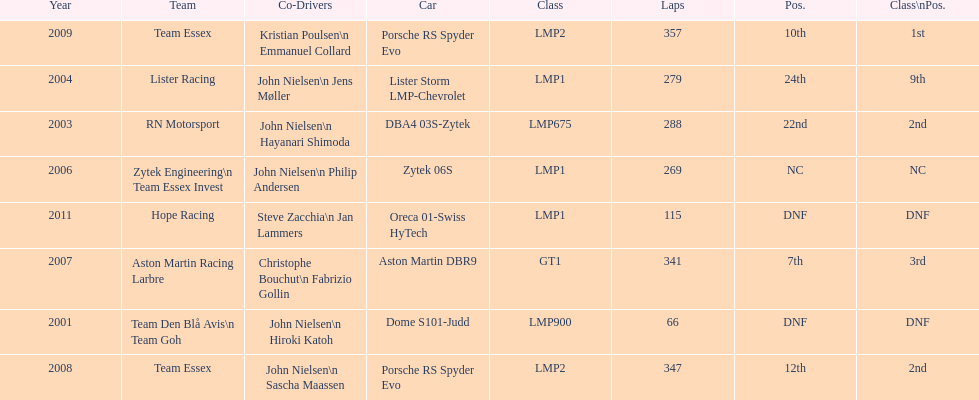How many times was the porsche rs spyder used in competition? 2. 